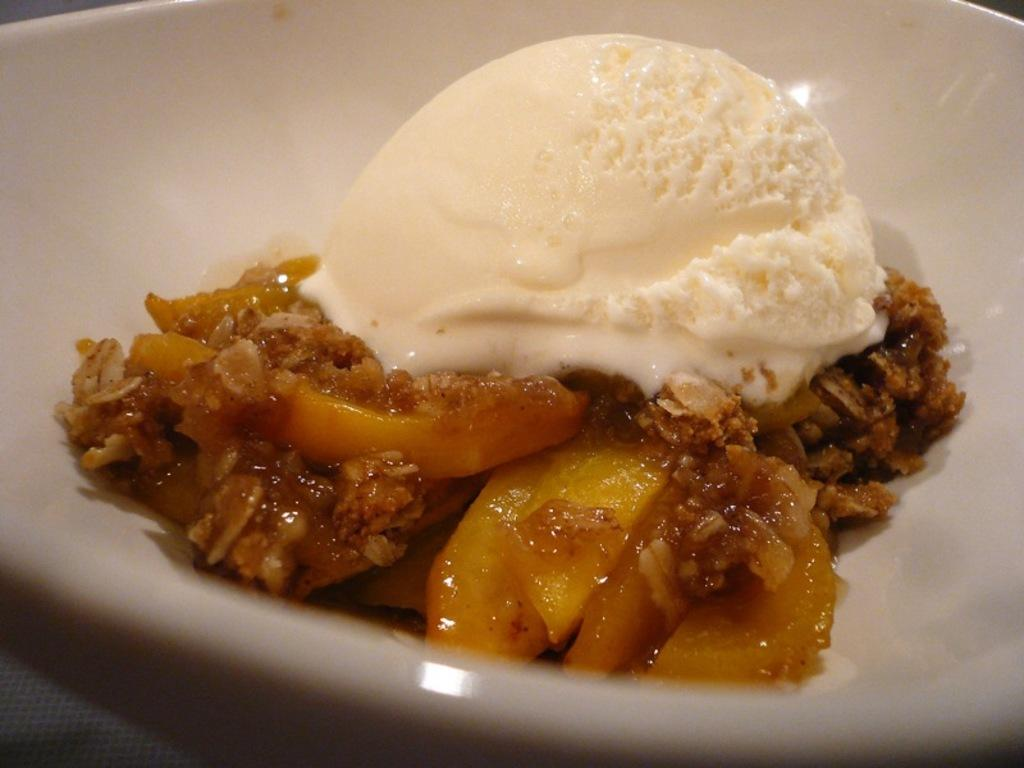What can be seen on the plate in the image? There is a food item on the plate. What is placed on top of the food item? A scoop of ice cream is placed on the food item. What color is the plate in the image? The plate is white. What type of grass can be seen growing around the plate in the image? There is no grass present in the image; it only features a plate with a food item and a scoop of ice cream. 